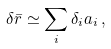<formula> <loc_0><loc_0><loc_500><loc_500>\delta \bar { r } \simeq \sum _ { i } \delta _ { i } a _ { i } \, ,</formula> 